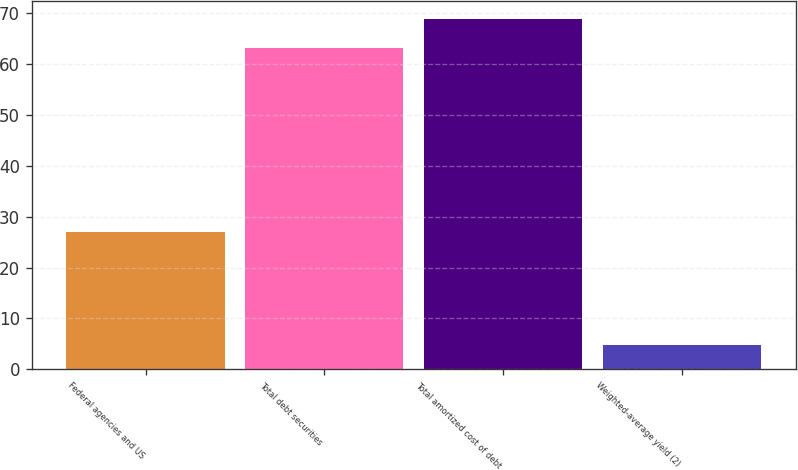Convert chart. <chart><loc_0><loc_0><loc_500><loc_500><bar_chart><fcel>Federal agencies and US<fcel>Total debt securities<fcel>Total amortized cost of debt<fcel>Weighted-average yield (2)<nl><fcel>27<fcel>63<fcel>68.83<fcel>4.71<nl></chart> 